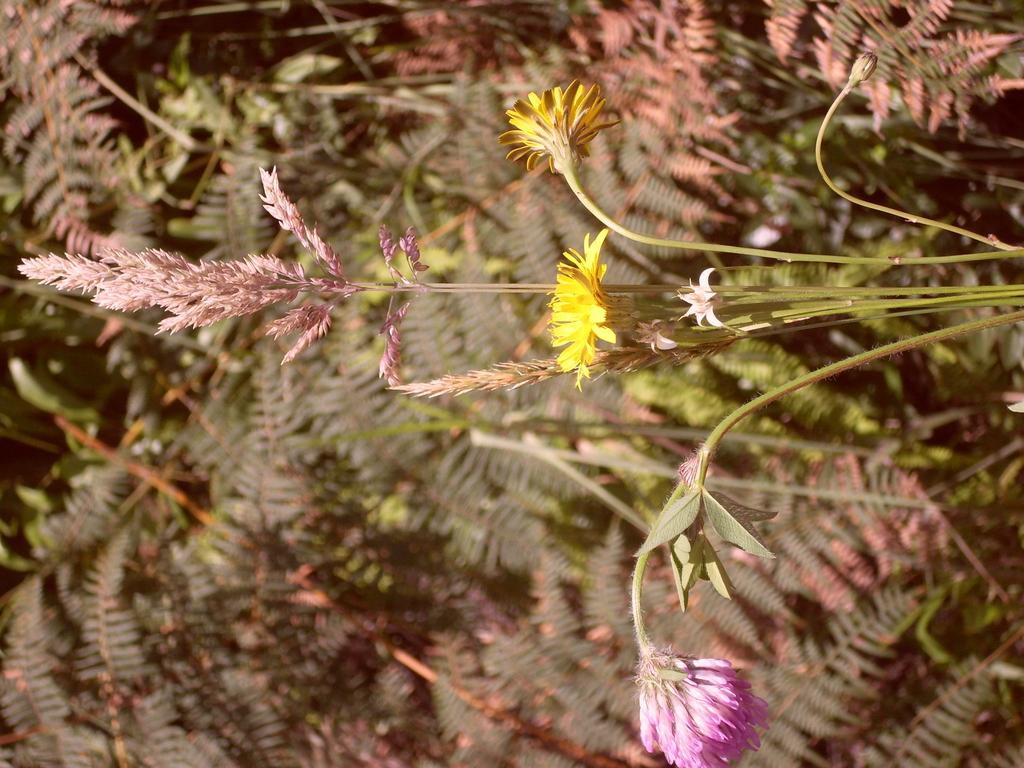What is located in the foreground of the image? There are flowers in the foreground of the image. What can be seen in the background of the image? There are plants in the background of the image. How many babies are crawling through the stamp in the image? There are no babies or stamps present in the image; it features flowers in the foreground and plants in the background. 